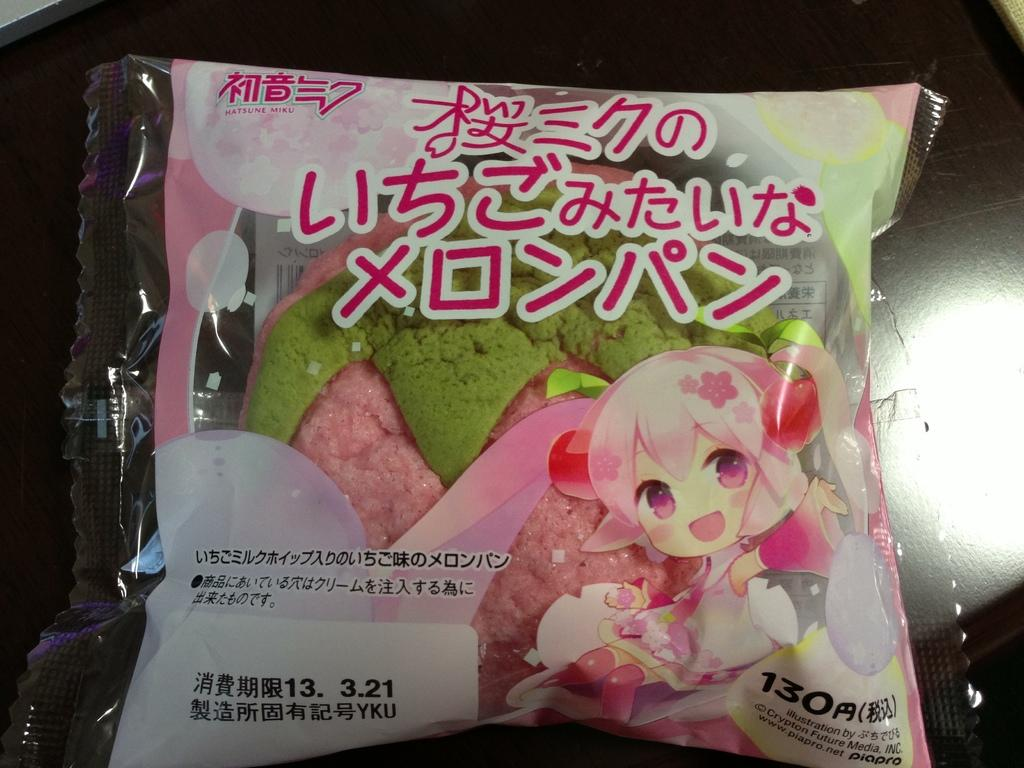What is the main object in the image? There is a packet in the image. What is the color of the surface the packet is on? The packet is on a black surface. What can be found on the packet? There is text and a cartoon image on the packet. What colors are the objects inside the packet? Inside the packet, there are green and pink color objects. How many sisters are depicted in the cartoon image on the packet? There are no sisters depicted in the cartoon image on the packet; it is a single cartoon character. 